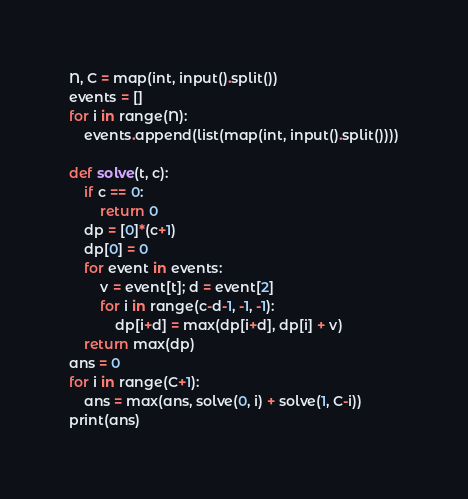Convert code to text. <code><loc_0><loc_0><loc_500><loc_500><_Python_>N, C = map(int, input().split())
events = []
for i in range(N):
    events.append(list(map(int, input().split())))

def solve(t, c):
    if c == 0:
        return 0
    dp = [0]*(c+1)
    dp[0] = 0
    for event in events:
        v = event[t]; d = event[2]
        for i in range(c-d-1, -1, -1):
            dp[i+d] = max(dp[i+d], dp[i] + v)
    return max(dp)
ans = 0
for i in range(C+1):
    ans = max(ans, solve(0, i) + solve(1, C-i))
print(ans)</code> 